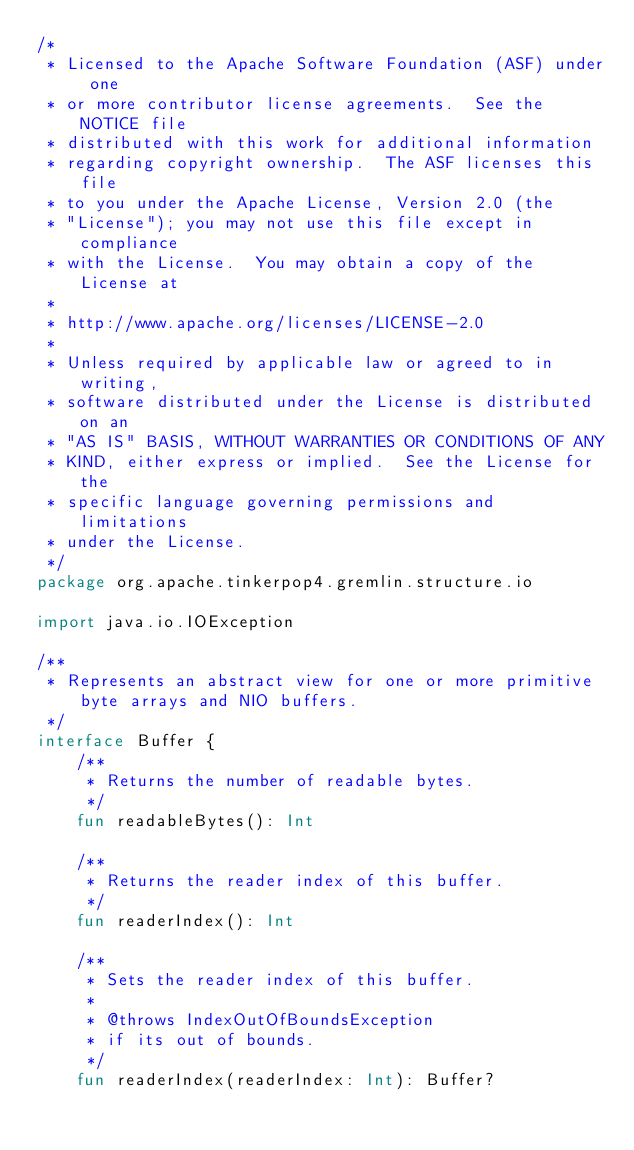Convert code to text. <code><loc_0><loc_0><loc_500><loc_500><_Kotlin_>/*
 * Licensed to the Apache Software Foundation (ASF) under one
 * or more contributor license agreements.  See the NOTICE file
 * distributed with this work for additional information
 * regarding copyright ownership.  The ASF licenses this file
 * to you under the Apache License, Version 2.0 (the
 * "License"); you may not use this file except in compliance
 * with the License.  You may obtain a copy of the License at
 *
 * http://www.apache.org/licenses/LICENSE-2.0
 *
 * Unless required by applicable law or agreed to in writing,
 * software distributed under the License is distributed on an
 * "AS IS" BASIS, WITHOUT WARRANTIES OR CONDITIONS OF ANY
 * KIND, either express or implied.  See the License for the
 * specific language governing permissions and limitations
 * under the License.
 */
package org.apache.tinkerpop4.gremlin.structure.io

import java.io.IOException

/**
 * Represents an abstract view for one or more primitive byte arrays and NIO buffers.
 */
interface Buffer {
    /**
     * Returns the number of readable bytes.
     */
    fun readableBytes(): Int

    /**
     * Returns the reader index of this buffer.
     */
    fun readerIndex(): Int

    /**
     * Sets the reader index of this buffer.
     *
     * @throws IndexOutOfBoundsException
     * if its out of bounds.
     */
    fun readerIndex(readerIndex: Int): Buffer?
</code> 